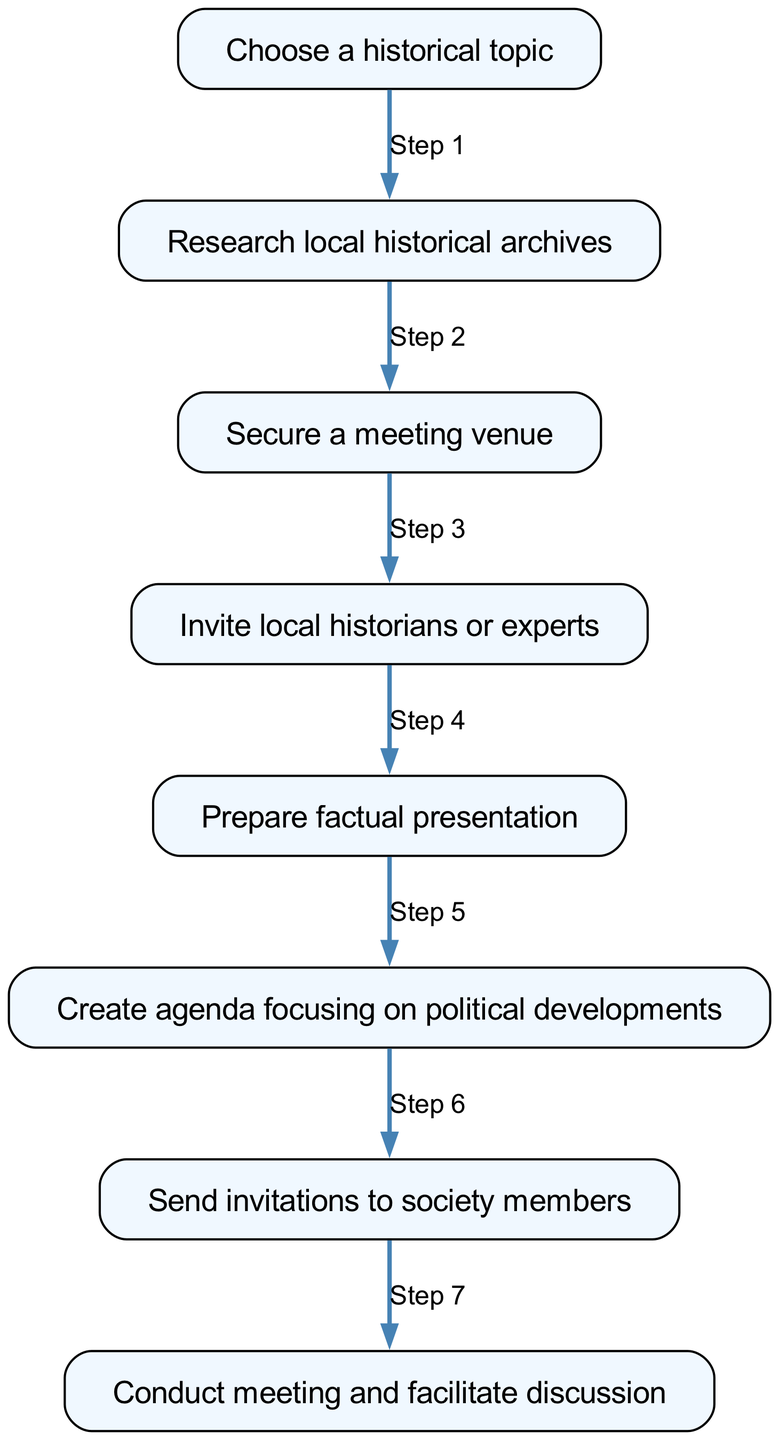What is the first step in organizing a local historical society meeting? The first step listed in the diagram is "Choose a historical topic," which is identified as the starting point of the instruction flow.
Answer: Choose a historical topic How many steps are there in total to organize the meeting? By counting the nodes from the diagram, there are eight steps listed to organize a local historical society meeting.
Answer: Eight What is the last action taken in this process? The final action mentioned in the diagram is "Conduct meeting and facilitate discussion," which indicates the end of the process.
Answer: Conduct meeting and facilitate discussion Which step involves inviting individuals to the meeting? The step that involves inviting individuals occurs after securing a venue and is described as "Invite local historians or experts," which directly addresses the invitation process.
Answer: Invite local historians or experts What topic should be focused on in the agenda? The agenda should focus on "political developments," as indicated in the step prepared specifically for this purpose.
Answer: Political developments What is the relationship between steps 7 and 8? The relationship is sequential; after sending invitations to society members in step 7, the next step 8 is to conduct the meeting and facilitate discussion, showing a direct flow of actions.
Answer: Sequential relationship How can you ensure the meeting is informative? You ensure the meeting is informative by preparing a "factual presentation," which is directly linked to enhancing the quality of information provided during the meeting.
Answer: Prepare factual presentation Which step follows the research of local archives? After the research of local historical archives, the next step is to "Secure a meeting venue," indicating a progression from research to planning.
Answer: Secure a meeting venue 